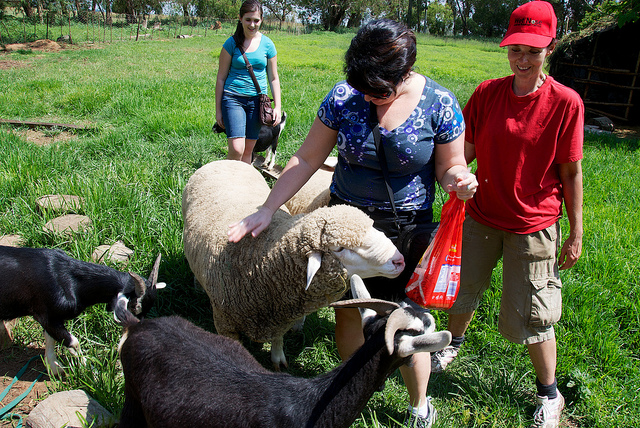How many people are present in the picture? There are three people present in the image. Two women, seemingly engaged with the animals, and a third person standing nearby who appears to be observing the interaction. 